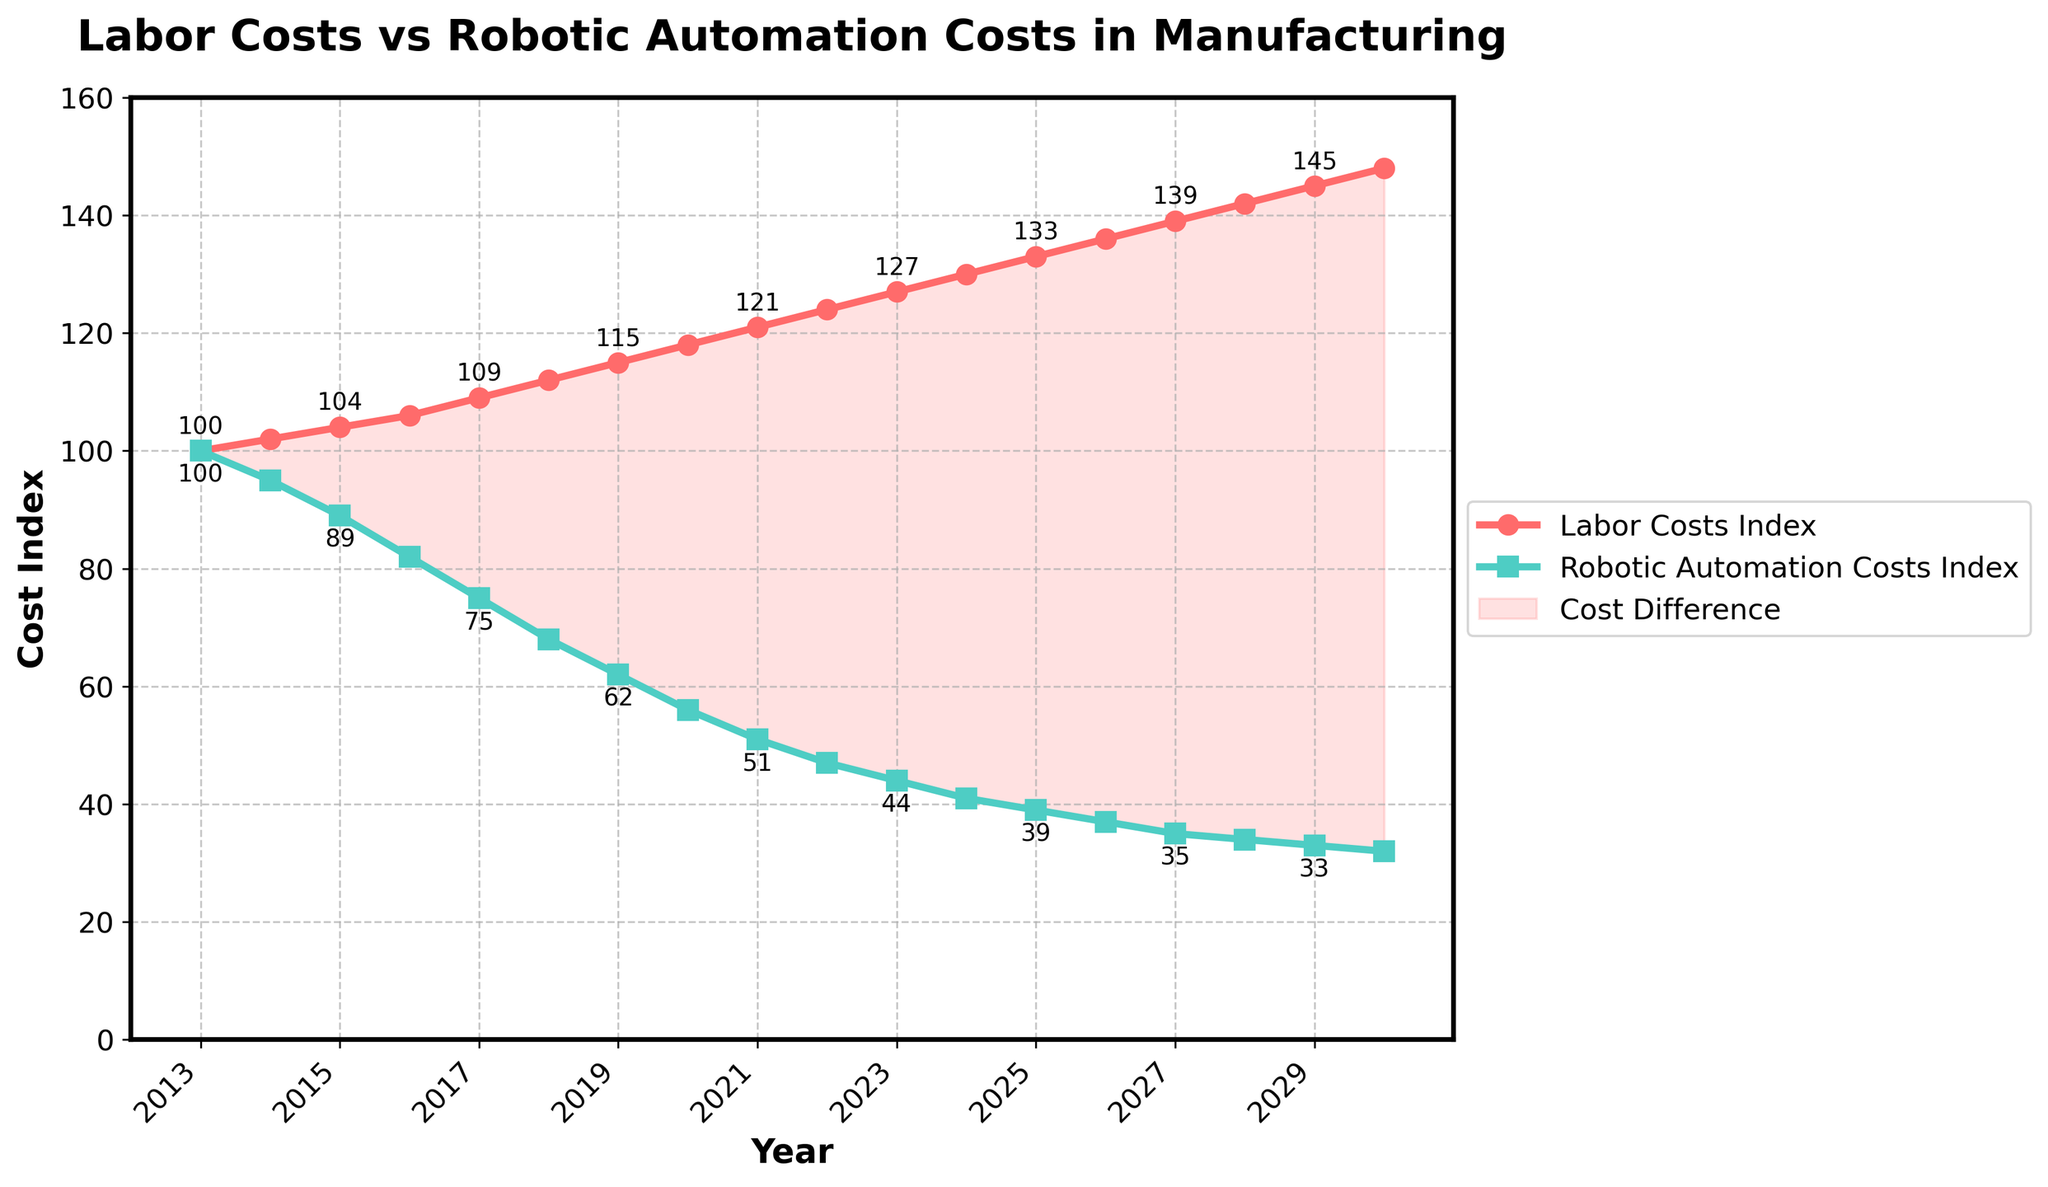What does the trend of labor costs and robotic automation costs over the past decade indicate? The trend shows that labor costs have been steadily increasing from 100 to 127, while robotic automation costs have been decreasing from 100 to 44. This inverse relationship indicates that labor is becoming more expensive, whereas automation is becoming more cost-effective.
Answer: Labor costs rising, automation costs falling What is the expected difference between labor costs and robotic automation costs in 2024? In 2024, labor costs are projected to be 130, and robotic automation costs are projected to be 41. The difference is 130 - 41 = 89.
Answer: 89 In what year are labor costs projected to be three times higher than robotic automation costs? To find the year when labor costs are three times higher than robotic automation costs, we need to check the ratio for each year. By reviewing the data, in 2024, labor costs are projected to be 130 and robotic automation costs are 41, which gives a ratio of approximately 130 / 41 ≈ 3.17. This confirms that in 2024, labor costs are just over three times higher than robotic automation costs.
Answer: 2024 Between which years is the cost difference between labor and robotic automation the greatest? Reviewing the visual trend, the greatest difference can be observed around 2030. In 2030, the difference is 148 (labor costs) - 32 (robotic automation costs) = 116.
Answer: 2030 When did robotic automation costs fall below 50% of labor costs for the first time? To determine the first year robotic automation costs fell below 50% of labor costs, we can see that in 2021, labor costs were 121 and robotic automation costs were 51. By calculating the percentage, we see 51 / 121 < 0.5. Thus, 2021 is the first year when robotic automation costs were less than half of labor costs.
Answer: 2021 What is the projected decrease in robotic automation costs from the beginning to the end of the period shown? At the beginning (2013), the cost index was 100. At the end (2030), it is projected to be 32. The decrease is 100 - 32 = 68.
Answer: 68 How would you describe the visual representation indicating the cost difference between labor and automation on the chart? The visual representation uses a filled area between the two lines (red for labor and green for automation) to highlight the difference. The filled area becomes wider over time, clearly indicating that the cost difference is increasing.
Answer: Filled area shows increasing cost difference By how much did labor costs increase from 2018 to 2022? In 2018, labor costs were 112. In 2022, they were 124. The increase is 124 - 112 = 12.
Answer: 12 Which year had the smallest numerical change in robotic automation costs compared to the previous year? Robotic automation costs change gradually. By examining year-to-year changes, the smallest numerical change is from 2028 to 2029, where the cost index changes from 34 to 33, a difference of just 1.
Answer: 2029 In 2030, how much higher are labor costs than robotic automation costs, in percentage terms? In 2030, labor costs are 148 and robotic automation costs are 32. To calculate the percentage difference: ((148 - 32) / 32) * 100% = 362.5%.
Answer: 362.5% 